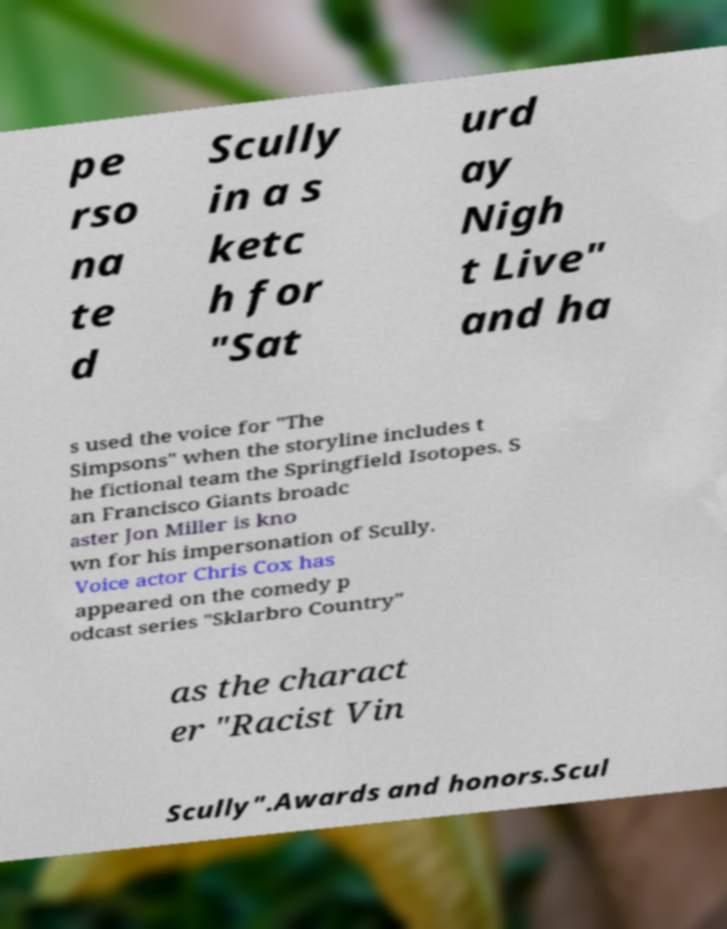Could you extract and type out the text from this image? pe rso na te d Scully in a s ketc h for "Sat urd ay Nigh t Live" and ha s used the voice for "The Simpsons" when the storyline includes t he fictional team the Springfield Isotopes. S an Francisco Giants broadc aster Jon Miller is kno wn for his impersonation of Scully. Voice actor Chris Cox has appeared on the comedy p odcast series "Sklarbro Country" as the charact er "Racist Vin Scully".Awards and honors.Scul 